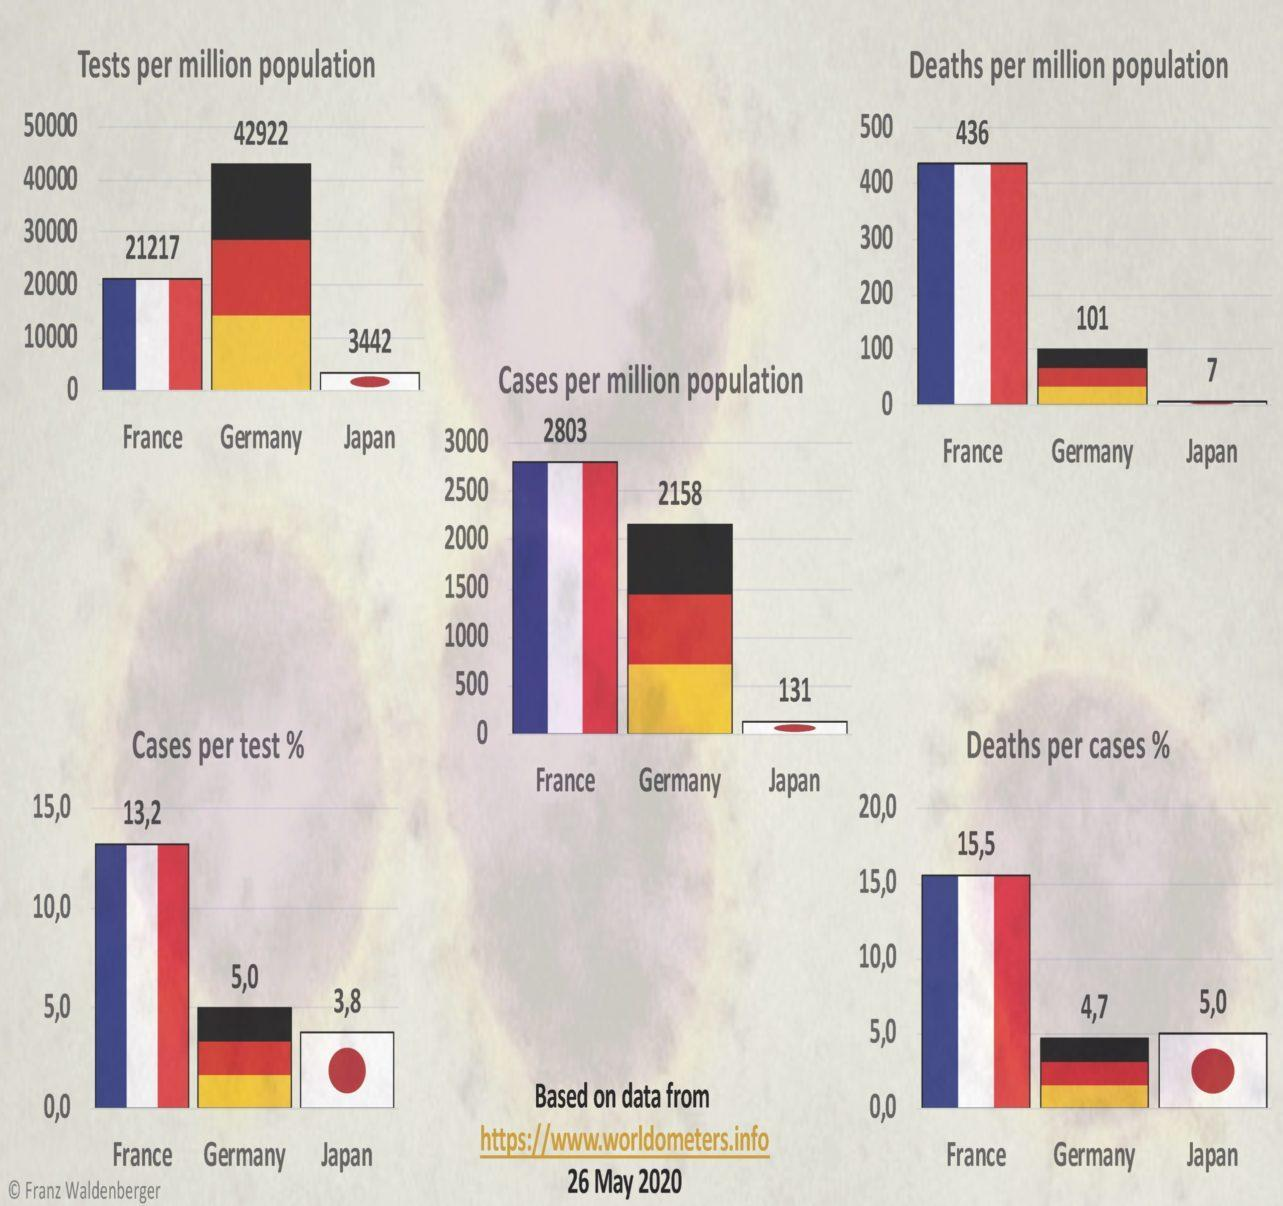What is the difference between deaths per million population in France and Germany?
Answer the question with a short phrase. 335 What is the difference between cases per million population in Germany and Japan? 2027 What is the difference between cases per million population in France and Germany? 645 What is the difference between cases and deaths per million population in Germany? 2057 